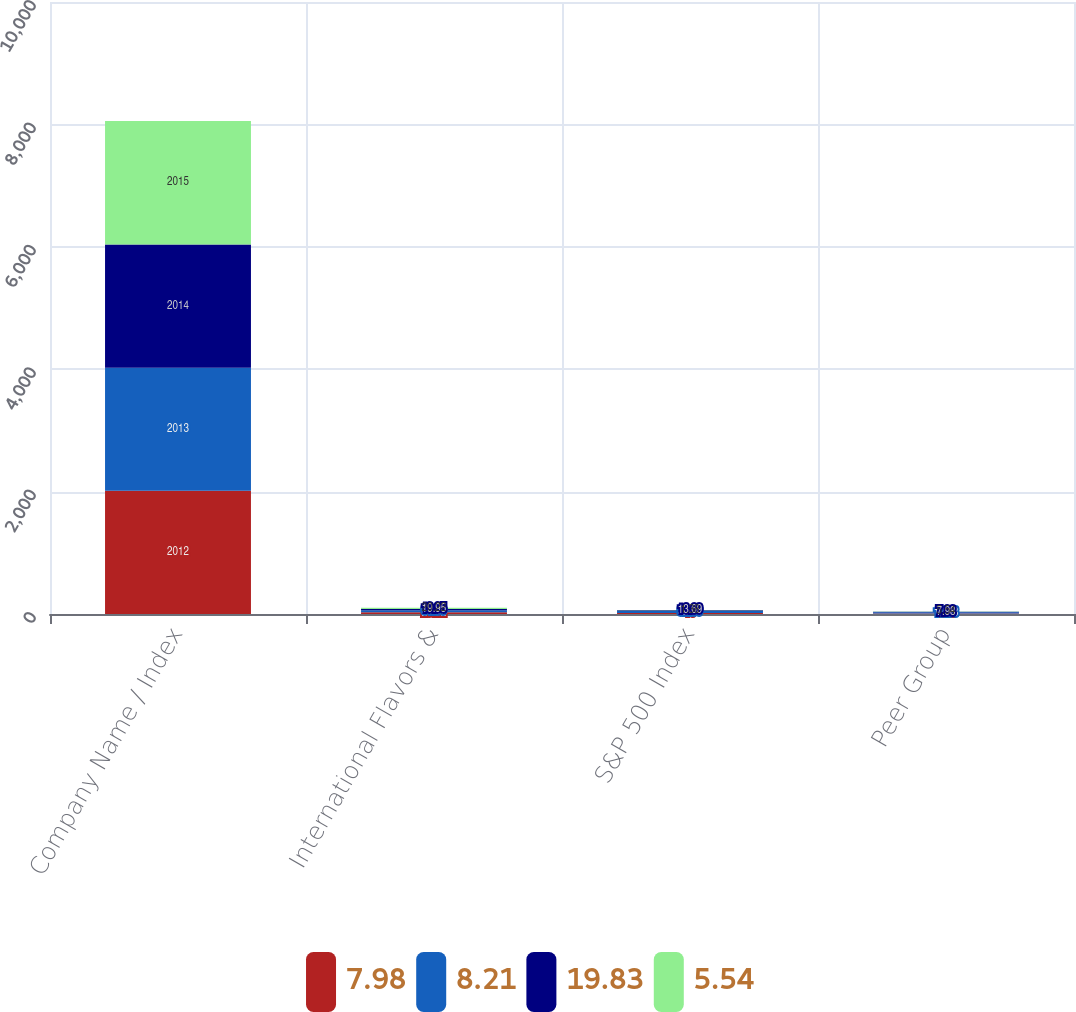Convert chart. <chart><loc_0><loc_0><loc_500><loc_500><stacked_bar_chart><ecel><fcel>Company Name / Index<fcel>International Flavors &<fcel>S&P 500 Index<fcel>Peer Group<nl><fcel>7.98<fcel>2012<fcel>29.72<fcel>16<fcel>8.21<nl><fcel>8.21<fcel>2013<fcel>31.59<fcel>32.39<fcel>19.83<nl><fcel>19.83<fcel>2014<fcel>19.95<fcel>13.69<fcel>7.98<nl><fcel>5.54<fcel>2015<fcel>20.22<fcel>1.38<fcel>5.54<nl></chart> 